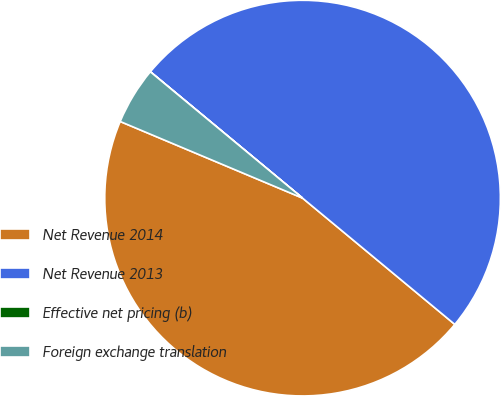Convert chart. <chart><loc_0><loc_0><loc_500><loc_500><pie_chart><fcel>Net Revenue 2014<fcel>Net Revenue 2013<fcel>Effective net pricing (b)<fcel>Foreign exchange translation<nl><fcel>45.31%<fcel>49.99%<fcel>0.01%<fcel>4.69%<nl></chart> 